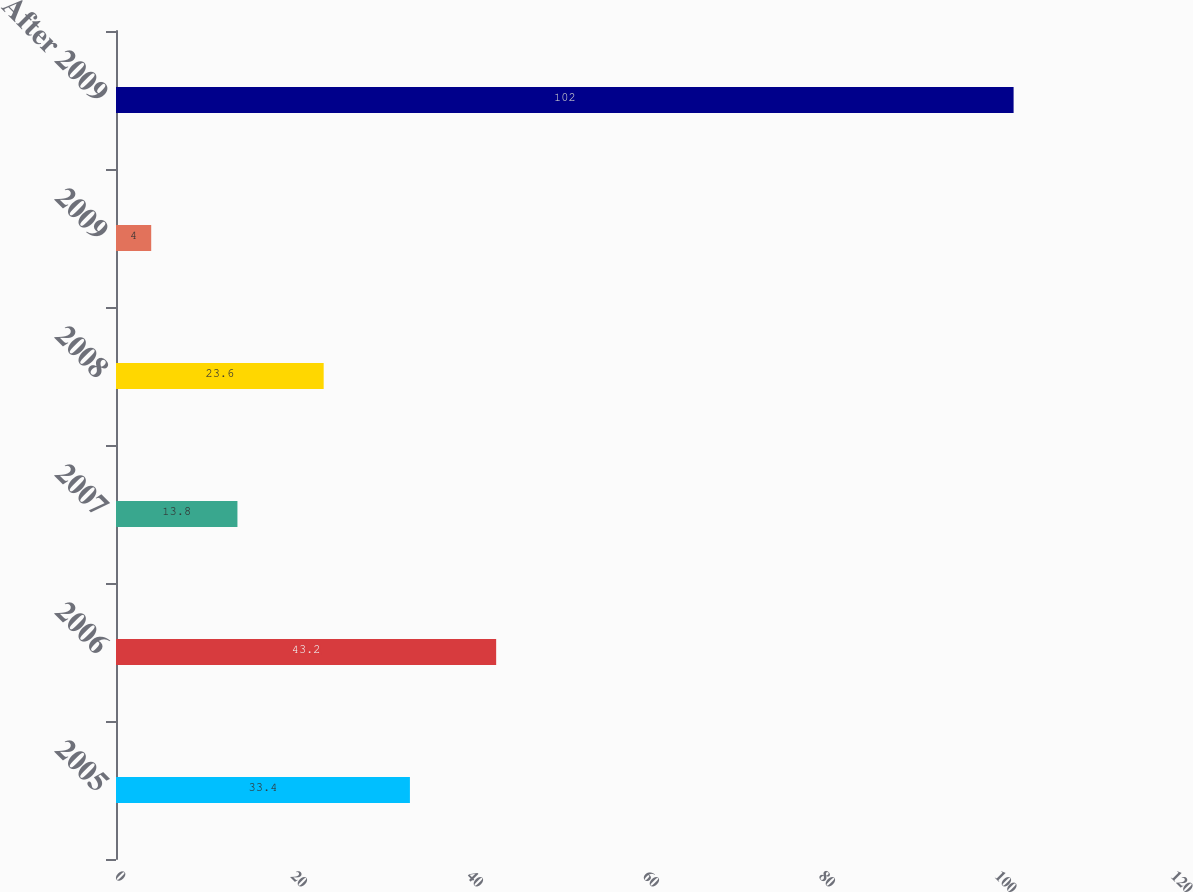<chart> <loc_0><loc_0><loc_500><loc_500><bar_chart><fcel>2005<fcel>2006<fcel>2007<fcel>2008<fcel>2009<fcel>After 2009<nl><fcel>33.4<fcel>43.2<fcel>13.8<fcel>23.6<fcel>4<fcel>102<nl></chart> 